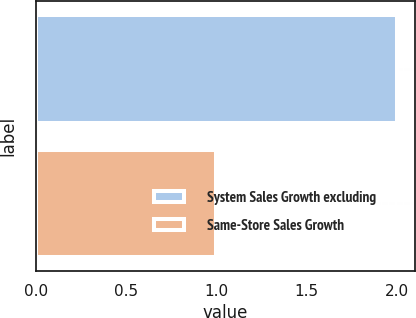Convert chart. <chart><loc_0><loc_0><loc_500><loc_500><bar_chart><fcel>System Sales Growth excluding<fcel>Same-Store Sales Growth<nl><fcel>2<fcel>1<nl></chart> 